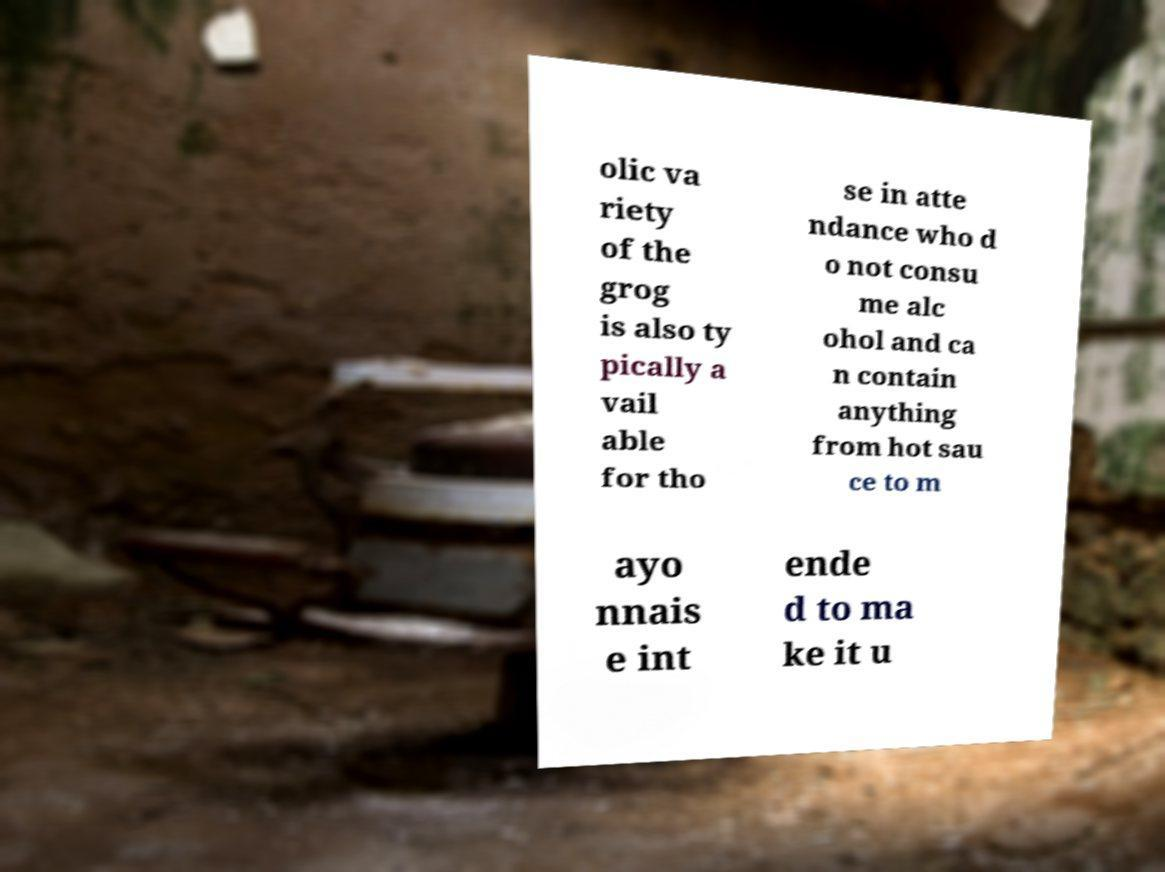Could you assist in decoding the text presented in this image and type it out clearly? olic va riety of the grog is also ty pically a vail able for tho se in atte ndance who d o not consu me alc ohol and ca n contain anything from hot sau ce to m ayo nnais e int ende d to ma ke it u 